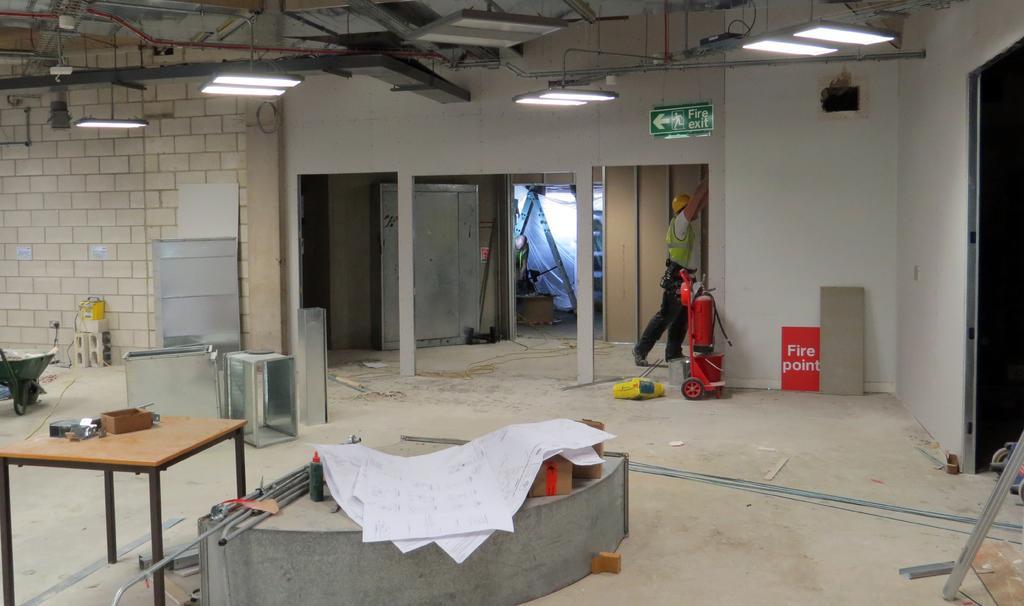Can you describe this image briefly? This image is taken inside a room, looking like it is under construction. At the background there is a walls with bricks and wooden doors with a sign board on it. At the top of the image there were a lights. At the bottom of the image there is a floor. In this room a man is standing, he is working. 